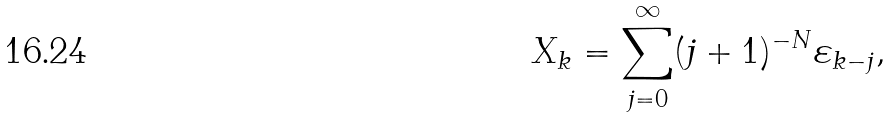Convert formula to latex. <formula><loc_0><loc_0><loc_500><loc_500>X _ { k } = \sum _ { j = 0 } ^ { \infty } ( j + 1 ) ^ { - N } \varepsilon _ { k - j } ,</formula> 